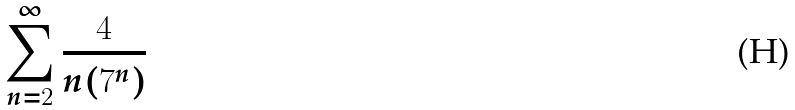Convert formula to latex. <formula><loc_0><loc_0><loc_500><loc_500>\sum _ { n = 2 } ^ { \infty } \frac { 4 } { n ( 7 ^ { n } ) }</formula> 